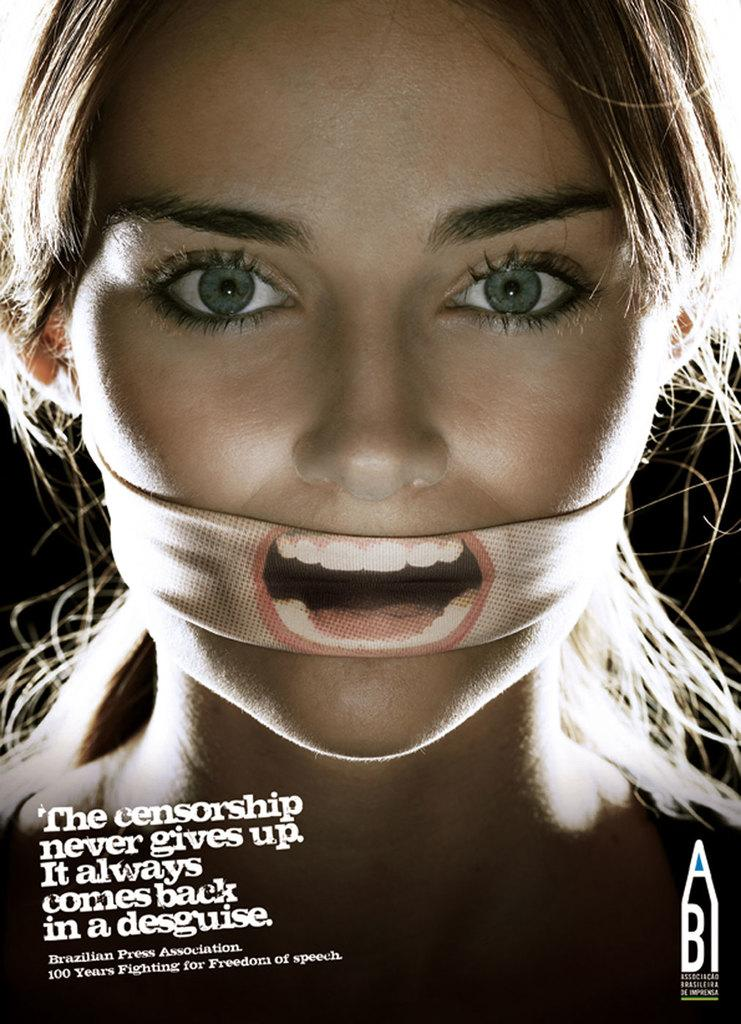Who is the main subject in the image? There is a woman in the image. What is the woman doing in the image? The woman is tying a cloth around her mouth. Is there any text present in the image? Yes, there is text in the left bottom corner of the image. Can you tell me how deep the river is in the image? There is no river present in the image; it features a woman tying a cloth around her mouth and text in the left bottom corner. What advice does the creator of the image give to the viewer? The creator of the image does not give any advice to the viewer, as the image is a static representation and does not convey any direct message or instruction. 